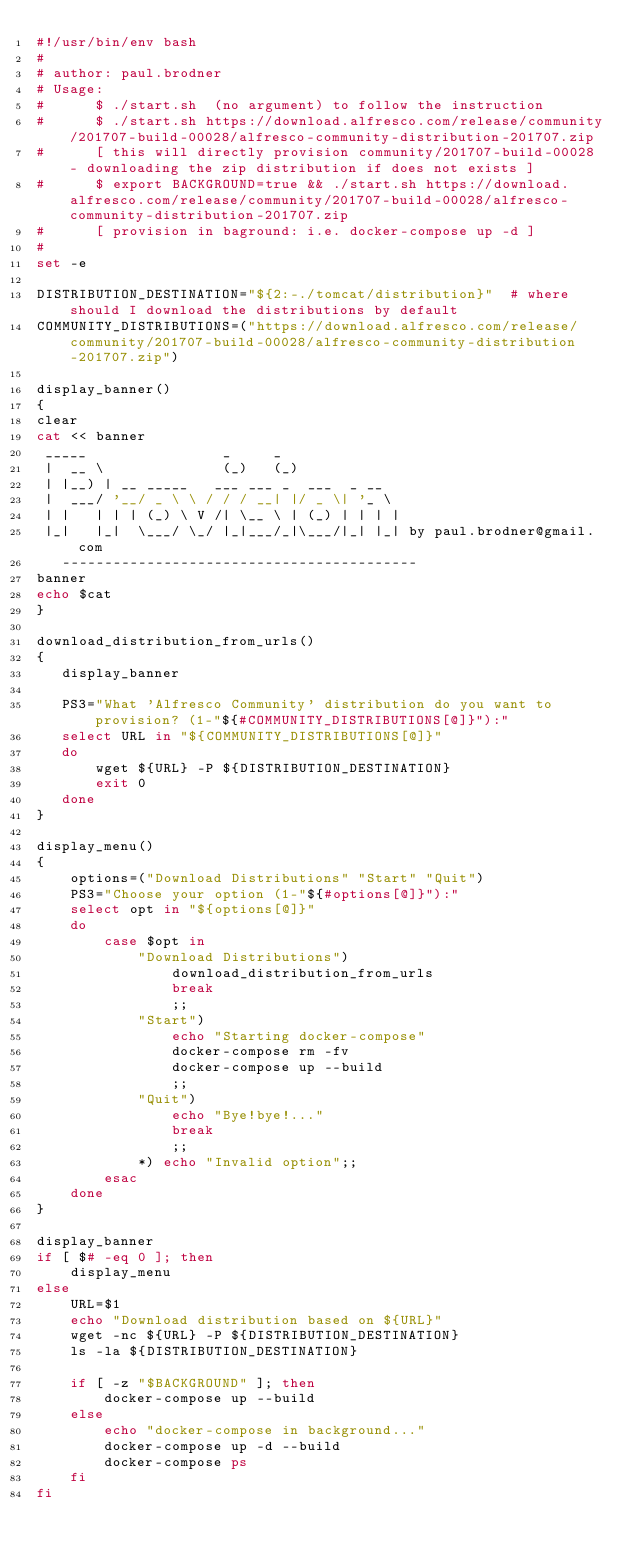<code> <loc_0><loc_0><loc_500><loc_500><_Bash_>#!/usr/bin/env bash
#
# author: paul.brodner
# Usage:
#      $ ./start.sh  (no argument) to follow the instruction
#      $ ./start.sh https://download.alfresco.com/release/community/201707-build-00028/alfresco-community-distribution-201707.zip
#      [ this will directly provision community/201707-build-00028 - downloading the zip distribution if does not exists ]
#      $ export BACKGROUND=true && ./start.sh https://download.alfresco.com/release/community/201707-build-00028/alfresco-community-distribution-201707.zip
#      [ provision in baground: i.e. docker-compose up -d ]
#
set -e

DISTRIBUTION_DESTINATION="${2:-./tomcat/distribution}"  # where should I download the distributions by default
COMMUNITY_DISTRIBUTIONS=("https://download.alfresco.com/release/community/201707-build-00028/alfresco-community-distribution-201707.zip")

display_banner()
{
clear
cat << banner
 _____                _     _             
 |  __ \              (_)   (_)            
 | |__) | __ _____   ___ ___ _  ___  _ __  
 |  ___/ '__/ _ \ \ / / / __| |/ _ \| '_ \ 
 | |   | | | (_) \ V /| \__ \ | (_) | | | |
 |_|   |_|  \___/ \_/ |_|___/_|\___/|_| |_| by paul.brodner@gmail.com
   ------------------------------------------
banner
echo $cat
}

download_distribution_from_urls()
{
   display_banner
   
   PS3="What 'Alfresco Community' distribution do you want to provision? (1-"${#COMMUNITY_DISTRIBUTIONS[@]}"):"
   select URL in "${COMMUNITY_DISTRIBUTIONS[@]}"
   do
       wget ${URL} -P ${DISTRIBUTION_DESTINATION}    
       exit 0
   done
}

display_menu()
{  
    options=("Download Distributions" "Start" "Quit")
    PS3="Choose your option (1-"${#options[@]}"):"
    select opt in "${options[@]}"
    do
        case $opt in                              
            "Download Distributions")
                download_distribution_from_urls
                break
                ;;  
            "Start")
                echo "Starting docker-compose"                
                docker-compose rm -fv
                docker-compose up --build
                ;;                                                    
            "Quit")
                echo "Bye!bye!..."                
                break
                ;;  
            *) echo "Invalid option";;
        esac
    done
}

display_banner
if [ $# -eq 0 ]; then    
    display_menu
else    
    URL=$1
    echo "Download distribution based on ${URL}"
    wget -nc ${URL} -P ${DISTRIBUTION_DESTINATION}
    ls -la ${DISTRIBUTION_DESTINATION}
    
    if [ -z "$BACKGROUND" ]; then
        docker-compose up --build
    else        
        echo "docker-compose in background..."
        docker-compose up -d --build
        docker-compose ps
    fi        
fi
</code> 